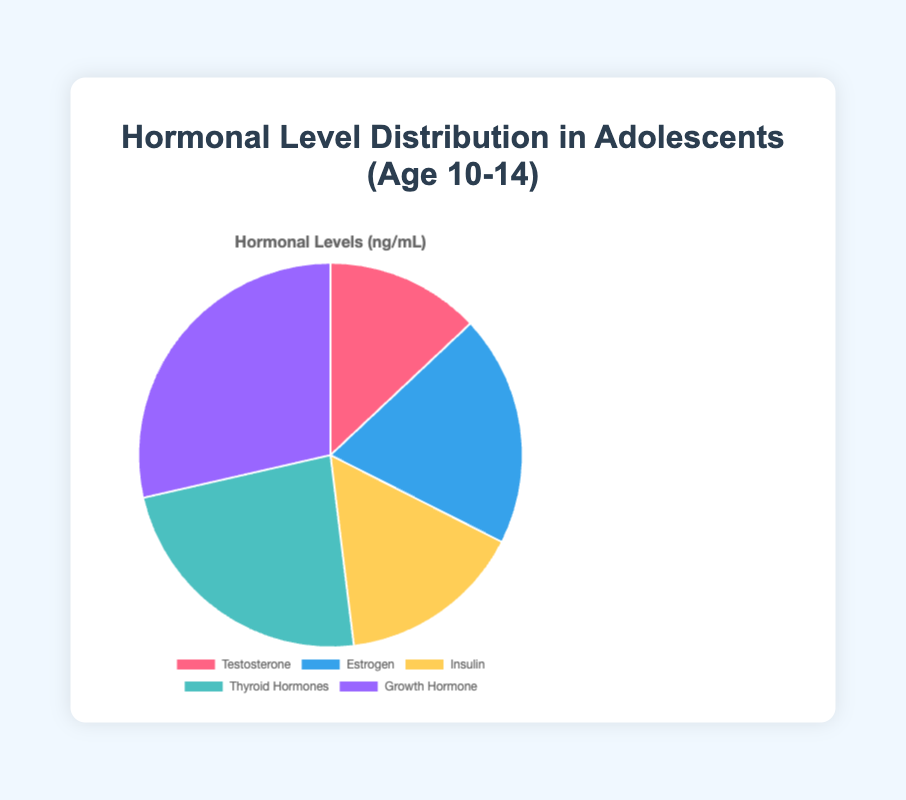What's the total hormonal level in the age group 10-14? To find the total hormonal level in the age group 10-14, sum the values: 10 (Testosterone) + 15 (Estrogen) + 12 (Insulin) + 18 (Thyroid Hormones) + 22 (Growth Hormone) = 77.
Answer: 77 Which hormone has the highest level in the age group 10-14? From the pie chart, we can see the largest segment corresponds to the Growth Hormone with a level of 22.
Answer: Growth Hormone How does the level of Estrogen compare to Testosterone in the age group 10-14? The level of Estrogen is 15, and the level of Testosterone is 10. Estrogen has a higher level than Testosterone by 5 units.
Answer: Estrogen is higher What is the difference between the levels of Insulin and Thyroid Hormones in the age group 10-14? Subtract the level of Insulin (12) from the level of Thyroid Hormones (18): 18 - 12 = 6.
Answer: 6 What is the average hormonal level for the age group 10-14? To find the average, sum up all the hormone levels and divide by the number of hormones: (10 + 15 + 12 + 18 + 22) / 5 = 77 / 5 = 15.4.
Answer: 15.4 Which hormone has the smallest level in the age group 10-14? From the pie chart, the smallest segment corresponds to Testosterone with a level of 10.
Answer: Testosterone What percentage of the total hormonal level is occupied by Growth Hormone in the age group 10-14? Growth Hormone is 22 out of the total 77. To find the percentage: (22 / 77) * 100 ≈ 28.57%.
Answer: 28.57% If we sum the levels of Testosterone and Estrogen, do they exceed the level of Growth Hormone in the age group 10-14? Testosterone and Estrogen summed are 10 + 15 = 25, which is greater than Growth Hormone's level of 22.
Answer: Yes By how much do the Thyroid Hormones outweigh the Insulin as a percentage of the total hormonal levels in the age group 10-14? Thyroid Hormones is 18, and Insulin is 12. The difference is 18 - 12 = 6. The total is 77. The percentage difference is (6 / 77) * 100 ≈ 7.79%.
Answer: 7.79% 